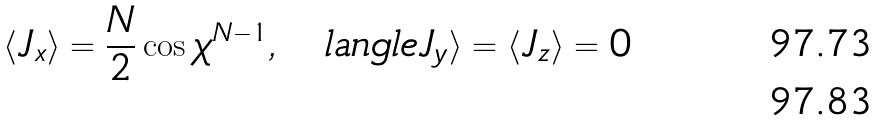<formula> <loc_0><loc_0><loc_500><loc_500>\langle J _ { x } \rangle = \frac { N } { 2 } \cos { \chi } ^ { N - 1 } , \quad l a n g l e J _ { y } \rangle = \langle J _ { z } \rangle = 0 \\</formula> 